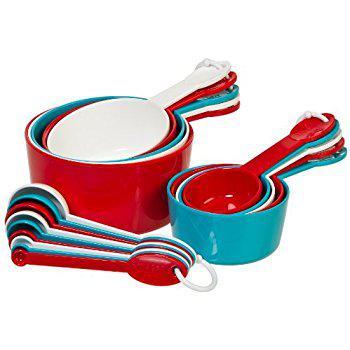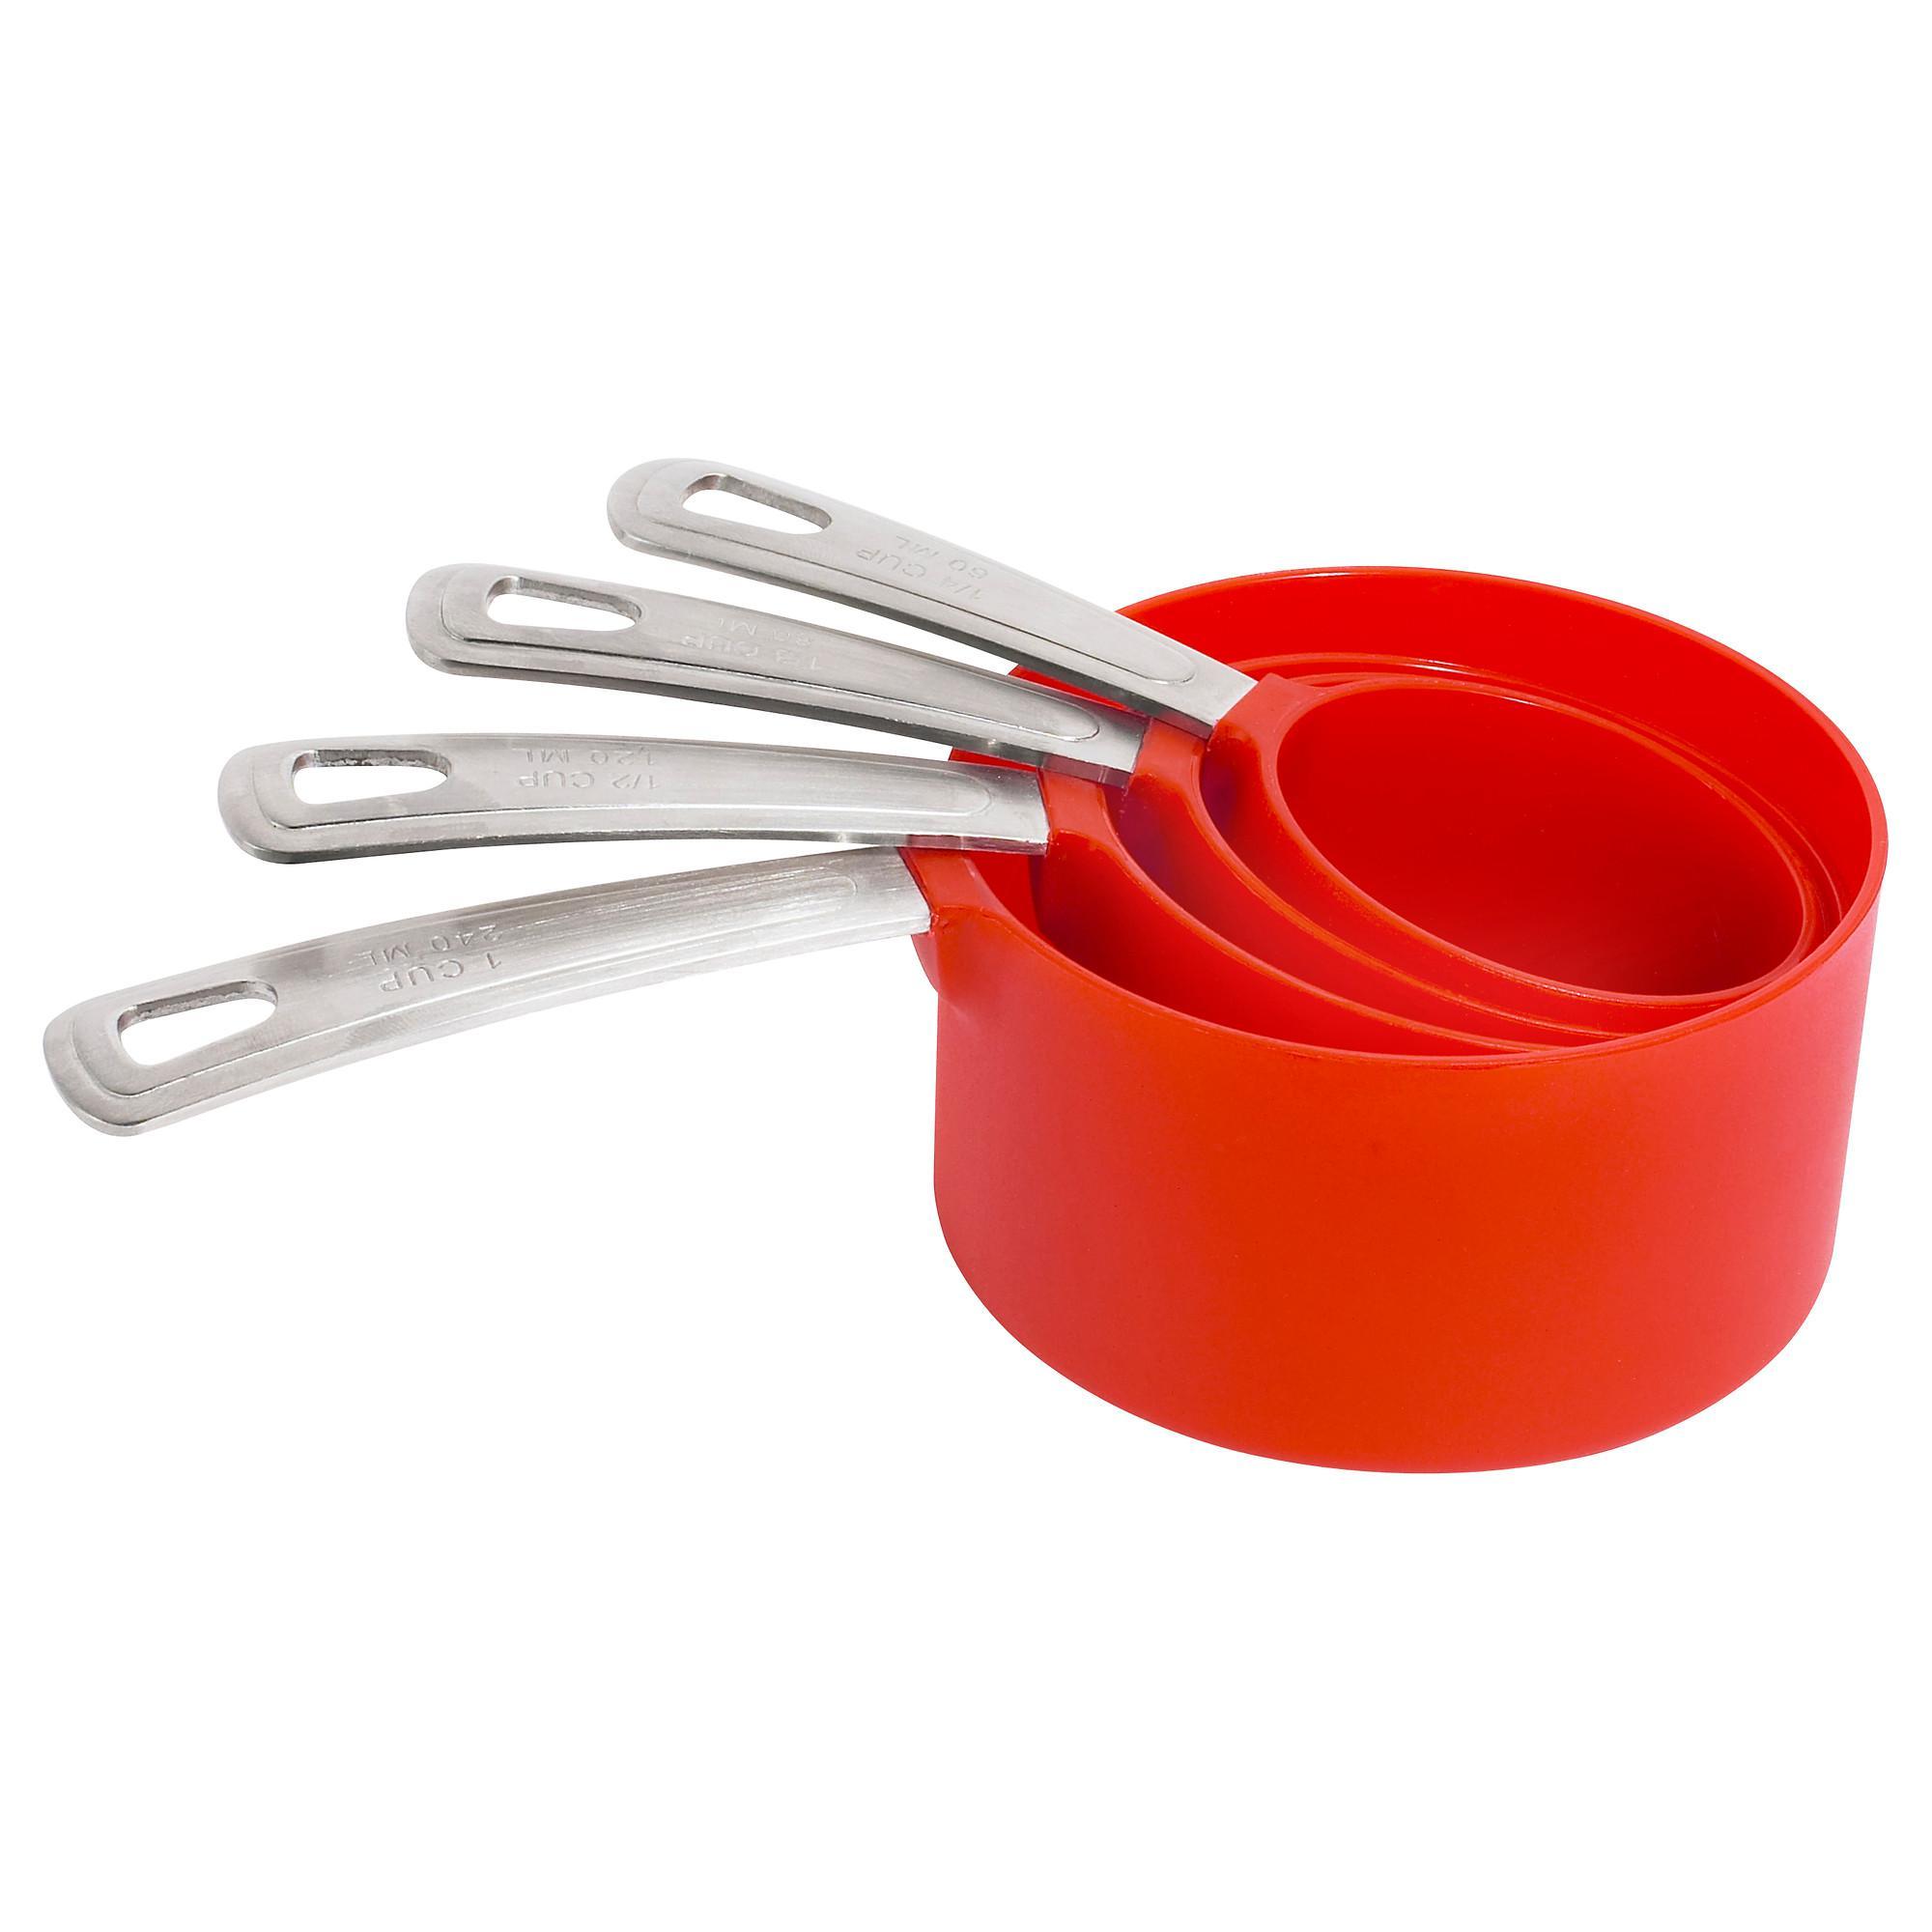The first image is the image on the left, the second image is the image on the right. Analyze the images presented: Is the assertion "One image contains a multicolored measuring set" valid? Answer yes or no. Yes. 